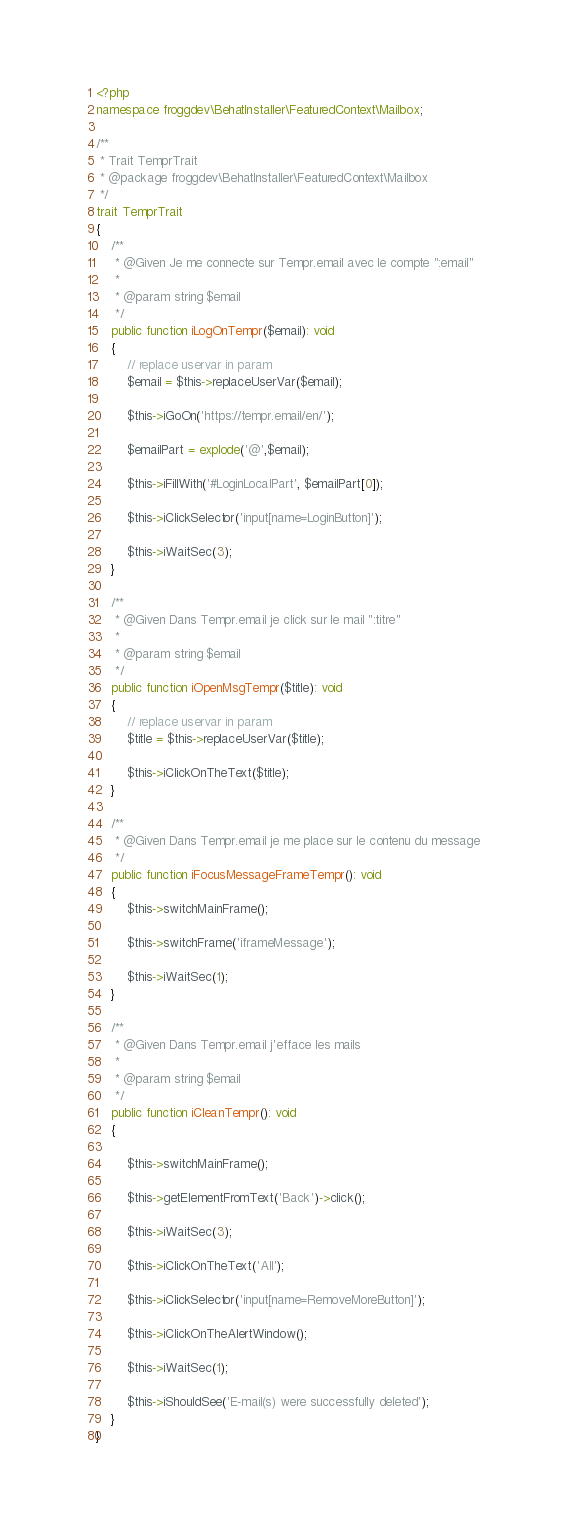<code> <loc_0><loc_0><loc_500><loc_500><_PHP_><?php
namespace froggdev\BehatInstaller\FeaturedContext\Mailbox;

/**
 * Trait TemprTrait
 * @package froggdev\BehatInstaller\FeaturedContext\Mailbox
 */
trait TemprTrait
{
    /**
     * @Given Je me connecte sur Tempr.email avec le compte ":email"
     *
     * @param string $email
     */
    public function iLogOnTempr($email): void
    {
        // replace uservar in param
        $email = $this->replaceUserVar($email);

        $this->iGoOn('https://tempr.email/en/');

        $emailPart = explode('@',$email);

        $this->iFillWith('#LoginLocalPart', $emailPart[0]);

        $this->iClickSelector('input[name=LoginButton]');

        $this->iWaitSec(3);
    }

    /**
     * @Given Dans Tempr.email je click sur le mail ":titre"
     *
     * @param string $email
     */
    public function iOpenMsgTempr($title): void
    {
        // replace uservar in param
        $title = $this->replaceUserVar($title);

        $this->iClickOnTheText($title);
    }

    /**
     * @Given Dans Tempr.email je me place sur le contenu du message
     */
    public function iFocusMessageFrameTempr(): void
    {
        $this->switchMainFrame();

        $this->switchFrame('iframeMessage');

        $this->iWaitSec(1);
    }

    /**
     * @Given Dans Tempr.email j'efface les mails
     *
     * @param string $email
     */
    public function iCleanTempr(): void
    {

        $this->switchMainFrame();

        $this->getElementFromText('Back')->click();

        $this->iWaitSec(3);

        $this->iClickOnTheText('All');

        $this->iClickSelector('input[name=RemoveMoreButton]');

        $this->iClickOnTheAlertWindow();

        $this->iWaitSec(1);

        $this->iShouldSee('E-mail(s) were successfully deleted');
    }
}
</code> 